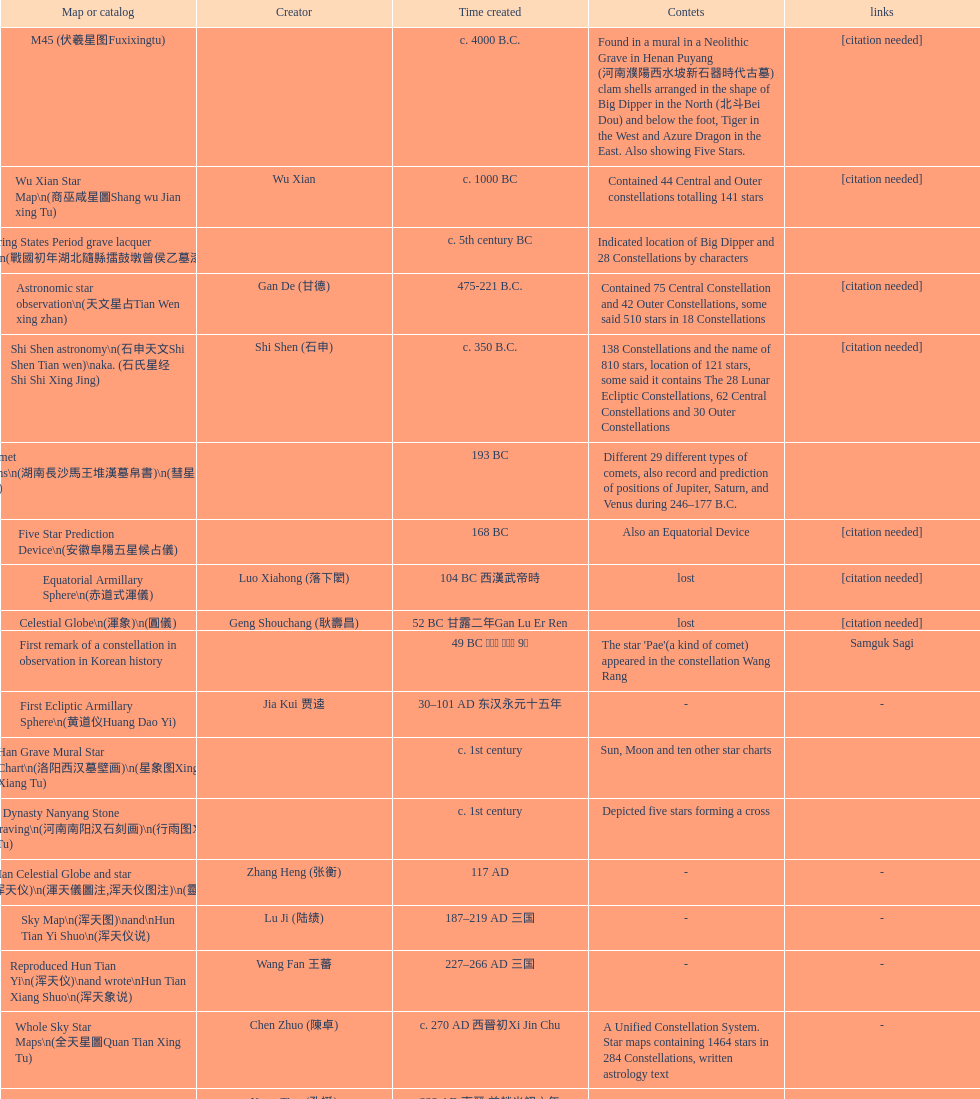Parse the full table. {'header': ['Map or catalog', 'Creator', 'Time created', 'Contets', 'links'], 'rows': [['M45 (伏羲星图Fuxixingtu)', '', 'c. 4000 B.C.', 'Found in a mural in a Neolithic Grave in Henan Puyang (河南濮陽西水坡新石器時代古墓) clam shells arranged in the shape of Big Dipper in the North (北斗Bei Dou) and below the foot, Tiger in the West and Azure Dragon in the East. Also showing Five Stars.', '[citation needed]'], ['Wu Xian Star Map\\n(商巫咸星圖Shang wu Jian xing Tu)', 'Wu Xian', 'c. 1000 BC', 'Contained 44 Central and Outer constellations totalling 141 stars', '[citation needed]'], ['Warring States Period grave lacquer box\\n(戰國初年湖北隨縣擂鼓墩曾侯乙墓漆箱)', '', 'c. 5th century BC', 'Indicated location of Big Dipper and 28 Constellations by characters', ''], ['Astronomic star observation\\n(天文星占Tian Wen xing zhan)', 'Gan De (甘德)', '475-221 B.C.', 'Contained 75 Central Constellation and 42 Outer Constellations, some said 510 stars in 18 Constellations', '[citation needed]'], ['Shi Shen astronomy\\n(石申天文Shi Shen Tian wen)\\naka. (石氏星经 Shi Shi Xing Jing)', 'Shi Shen (石申)', 'c. 350 B.C.', '138 Constellations and the name of 810 stars, location of 121 stars, some said it contains The 28 Lunar Ecliptic Constellations, 62 Central Constellations and 30 Outer Constellations', '[citation needed]'], ['Han Comet Diagrams\\n(湖南長沙馬王堆漢墓帛書)\\n(彗星圖Meng xing Tu)', '', '193 BC', 'Different 29 different types of comets, also record and prediction of positions of Jupiter, Saturn, and Venus during 246–177 B.C.', ''], ['Five Star Prediction Device\\n(安徽阜陽五星候占儀)', '', '168 BC', 'Also an Equatorial Device', '[citation needed]'], ['Equatorial Armillary Sphere\\n(赤道式渾儀)', 'Luo Xiahong (落下閎)', '104 BC 西漢武帝時', 'lost', '[citation needed]'], ['Celestial Globe\\n(渾象)\\n(圓儀)', 'Geng Shouchang (耿壽昌)', '52 BC 甘露二年Gan Lu Er Ren', 'lost', '[citation needed]'], ['First remark of a constellation in observation in Korean history', '', '49 BC 혁거세 거서간 9년', "The star 'Pae'(a kind of comet) appeared in the constellation Wang Rang", 'Samguk Sagi'], ['First Ecliptic Armillary Sphere\\n(黄道仪Huang Dao Yi)', 'Jia Kui 贾逵', '30–101 AD 东汉永元十五年', '-', '-'], ['Han Grave Mural Star Chart\\n(洛阳西汉墓壁画)\\n(星象图Xing Xiang Tu)', '', 'c. 1st century', 'Sun, Moon and ten other star charts', ''], ['Han Dynasty Nanyang Stone Engraving\\n(河南南阳汉石刻画)\\n(行雨图Xing Yu Tu)', '', 'c. 1st century', 'Depicted five stars forming a cross', ''], ['Eastern Han Celestial Globe and star maps\\n(浑天仪)\\n(渾天儀圖注,浑天仪图注)\\n(靈憲,灵宪)', 'Zhang Heng (张衡)', '117 AD', '-', '-'], ['Sky Map\\n(浑天图)\\nand\\nHun Tian Yi Shuo\\n(浑天仪说)', 'Lu Ji (陆绩)', '187–219 AD 三国', '-', '-'], ['Reproduced Hun Tian Yi\\n(浑天仪)\\nand wrote\\nHun Tian Xiang Shuo\\n(浑天象说)', 'Wang Fan 王蕃', '227–266 AD 三国', '-', '-'], ['Whole Sky Star Maps\\n(全天星圖Quan Tian Xing Tu)', 'Chen Zhuo (陳卓)', 'c. 270 AD 西晉初Xi Jin Chu', 'A Unified Constellation System. Star maps containing 1464 stars in 284 Constellations, written astrology text', '-'], ['Equatorial Armillary Sphere\\n(渾儀Hun Xi)', 'Kong Ting (孔挺)', '323 AD 東晉 前趙光初六年', 'level being used in this kind of device', '-'], ['Northern Wei Period Iron Armillary Sphere\\n(鐵渾儀)', 'Hu Lan (斛蘭)', 'Bei Wei\\plevel being used in this kind of device', '-', ''], ['Southern Dynasties Period Whole Sky Planetarium\\n(渾天象Hun Tian Xiang)', 'Qian Lezhi (錢樂之)', '443 AD 南朝劉宋元嘉年間', 'used red, black and white to differentiate stars from different star maps from Shi Shen, Gan De and Wu Xian 甘, 石, 巫三家星', '-'], ['Northern Wei Grave Dome Star Map\\n(河南洛陽北魏墓頂星圖)', '', '526 AD 北魏孝昌二年', 'about 300 stars, including the Big Dipper, some stars are linked by straight lines to form constellation. The Milky Way is also shown.', ''], ['Water-powered Planetarium\\n(水力渾天儀)', 'Geng Xun (耿詢)', 'c. 7th century 隋初Sui Chu', '-', '-'], ['Lingtai Miyuan\\n(靈台秘苑)', 'Yu Jicai (庾季才) and Zhou Fen (周墳)', '604 AD 隋Sui', 'incorporated star maps from different sources', '-'], ['Tang Dynasty Whole Sky Ecliptic Armillary Sphere\\n(渾天黃道儀)', 'Li Chunfeng 李淳風', '667 AD 貞觀七年', 'including Elliptic and Moon orbit, in addition to old equatorial design', '-'], ['The Dunhuang star map\\n(燉煌)', 'Dun Huang', '705–710 AD', '1,585 stars grouped into 257 clusters or "asterisms"', ''], ['Turfan Tomb Star Mural\\n(新疆吐鲁番阿斯塔那天文壁画)', '', '250–799 AD 唐', '28 Constellations, Milkyway and Five Stars', ''], ['Picture of Fuxi and Nüwa 新疆阿斯達那唐墓伏羲Fu Xi 女媧NV Wa像Xiang', '', 'Tang Dynasty', 'Picture of Fuxi and Nuwa together with some constellations', 'Image:Nuva fuxi.gif'], ['Tang Dynasty Armillary Sphere\\n(唐代渾儀Tang Dai Hun Xi)\\n(黃道遊儀Huang dao you xi)', 'Yixing Monk 一行和尚 (张遂)Zhang Sui and Liang Lingzan 梁令瓚', '683–727 AD', 'based on Han Dynasty Celestial Globe, recalibrated locations of 150 stars, determined that stars are moving', ''], ['Tang Dynasty Indian Horoscope Chart\\n(梵天火羅九曜)', 'Yixing Priest 一行和尚 (张遂)\\pZhang Sui\\p683–727 AD', 'simple diagrams of the 28 Constellation', '', ''], ['Kitora Kofun 法隆寺FaLong Si\u3000キトラ古墳 in Japan', '', 'c. late 7th century – early 8th century', 'Detailed whole sky map', ''], ['Treatise on Astrology of the Kaiyuan Era\\n(開元占経,开元占经Kai Yuan zhang Jing)', 'Gautama Siddha', '713 AD –', 'Collection of the three old star charts from Shi Shen, Gan De and Wu Xian. One of the most renowned collection recognized academically.', '-'], ['Big Dipper\\n(山東嘉祥武梁寺石刻北斗星)', '', '–', 'showing stars in Big Dipper', ''], ['Prajvalonisa Vjrabhairava Padvinasa-sri-dharani Scroll found in Japan 熾盛光佛頂大威德銷災吉祥陀羅尼經卷首扉畫', '', '972 AD 北宋開寶五年', 'Chinese 28 Constellations and Western Zodiac', '-'], ['Tangut Khara-Khoto (The Black City) Star Map 西夏黑水城星圖', '', '940 AD', 'A typical Qian Lezhi Style Star Map', '-'], ['Star Chart 五代吳越文穆王前元瓘墓石刻星象圖', '', '941–960 AD', '-', ''], ['Ancient Star Map 先天图 by 陈抟Chen Tuan', '', 'c. 11th Chen Tuan 宋Song', 'Perhaps based on studying of Puyong Ancient Star Map', 'Lost'], ['Song Dynasty Bronze Armillary Sphere 北宋至道銅渾儀', 'Han Xianfu 韓顯符', '1006 AD 宋道元年十二月', 'Similar to the Simplified Armillary by Kong Ting 孔挺, 晁崇 Chao Chong, 斛蘭 Hu Lan', '-'], ['Song Dynasty Bronze Armillary Sphere 北宋天文院黄道渾儀', 'Shu Yijian 舒易簡, Yu Yuan 于渊, Zhou Cong 周琮', '宋皇祐年中', 'Similar to the Armillary by Tang Dynasty Liang Lingzan 梁令瓚 and Yi Xing 一行', '-'], ['Song Dynasty Armillary Sphere 北宋簡化渾儀', 'Shen Kuo 沈括 and Huangfu Yu 皇甫愈', '1089 AD 熙寧七年', 'Simplied version of Tang Dynasty Device, removed the rarely used moon orbit.', '-'], ['Five Star Charts (新儀象法要)', 'Su Song 蘇頌', '1094 AD', '1464 stars grouped into 283 asterisms', 'Image:Su Song Star Map 1.JPG\\nImage:Su Song Star Map 2.JPG'], ['Song Dynasty Water-powered Planetarium 宋代 水运仪象台', 'Su Song 蘇頌 and Han Gonglian 韩公廉', 'c. 11th century', '-', ''], ['Liao Dynasty Tomb Dome Star Map 遼宣化张世卿墓頂星圖', '', '1116 AD 遼天庆六年', 'shown both the Chinese 28 Constellation encircled by Babylonian Zodiac', ''], ["Star Map in a woman's grave (江西德安 南宋周氏墓星相图)", '', '1127–1279 AD', 'Milky Way and 57 other stars.', ''], ['Hun Tian Yi Tong Xing Xiang Quan Tu, Suzhou Star Chart (蘇州石刻天文圖),淳祐天文図', 'Huang Shang (黃裳)', 'created in 1193, etched to stone in 1247 by Wang Zhi Yuan 王致遠', '1434 Stars grouped into 280 Asterisms in Northern Sky map', ''], ['Yuan Dynasty Simplified Armillary Sphere 元代簡儀', 'Guo Shou Jing 郭守敬', '1276–1279', 'Further simplied version of Song Dynasty Device', ''], ['Japanese Star Chart 格子月進図', '', '1324', 'Similar to Su Song Star Chart, original burned in air raids during World War II, only pictures left. Reprinted in 1984 by 佐佐木英治', ''], ['天象列次分野之図(Cheonsang Yeolcha Bunyajido)', '', '1395', 'Korean versions of Star Map in Stone. It was made in Chosun Dynasty and the constellation names were written in Chinese letter. The constellations as this was found in Japanese later. Contained 1,464 stars.', ''], ['Japanese Star Chart 瀧谷寺 天之図', '', 'c. 14th or 15th centuries 室町中期以前', '-', ''], ["Korean King Sejong's Armillary sphere", '', '1433', '-', ''], ['Star Chart', 'Mao Kun 茅坤', 'c. 1422', 'Polaris compared with Southern Cross and Alpha Centauri', 'zh:郑和航海图'], ['Korean Tomb', '', 'c. late 14th century', 'Big Dipper', ''], ['Ming Ancient Star Chart 北京隆福寺(古星圖)', '', 'c. 1453 明代', '1420 Stars, possibly based on old star maps from Tang Dynasty', ''], ['Chanshu Star Chart (明常熟石刻天文圖)', '', '1506', 'Based on Suzhou Star Chart, Northern Sky observed at 36.8 degrees North Latitude, 1466 stars grouped into 284 asterism', '-'], ['Ming Dynasty Star Map (渾蓋通憲圖說)', 'Matteo Ricci 利玛窦Li Ma Dou, recorded by Li Zhizao 李之藻', 'c. 1550', '-', ''], ['Tian Wun Tu (天问图)', 'Xiao Yun Cong 萧云从', 'c. 1600', 'Contained mapping of 12 constellations and 12 animals', ''], ['Zhou Tian Xuan Ji Tu (周天璇玑图) and He He Si Xiang Tu (和合四象圖) in Xing Ming Gui Zhi (性命圭旨)', 'by 尹真人高第弟子 published by 余永宁', '1615', 'Drawings of Armillary Sphere and four Chinese Celestial Animals with some notes. Related to Taoism.', ''], ['Korean Astronomy Book "Selected and Systematized Astronomy Notes" 天文類抄', '', '1623~1649', 'Contained some star maps', ''], ['Ming Dynasty General Star Map (赤道南北兩總星圖)', 'Xu Guang ci 徐光啟 and Adam Schall von Bell Tang Ruo Wang湯若望', '1634', '-', ''], ['Ming Dynasty diagrams of Armillary spheres and Celestial Globes', 'Xu Guang ci 徐光啟', 'c. 1699', '-', ''], ['Ming Dynasty Planetarium Machine (渾象 Hui Xiang)', '', 'c. 17th century', 'Ecliptic, Equator, and dividers of 28 constellation', ''], ['Copper Plate Star Map stored in Korea', '', '1652 順治九年shun zi jiu nian', '-', ''], ['Japanese Edo period Star Chart 天象列次之図 based on 天象列次分野之図 from Korean', 'Harumi Shibukawa 渋川春海Bu Chuan Chun Mei(保井春海Bao Jing Chun Mei)', '1670 寛文十年', '-', ''], ['The Celestial Globe 清康熙 天體儀', 'Ferdinand Verbiest 南懷仁', '1673', '1876 stars grouped into 282 asterisms', ''], ['Picture depicted Song Dynasty fictional astronomer (呉用 Wu Yong) with a Celestial Globe (天體儀)', 'Japanese painter', '1675', 'showing top portion of a Celestial Globe', 'File:Chinese astronomer 1675.jpg'], ['Japanese Edo period Star Chart 天文分野之図', 'Harumi Shibukawa 渋川春海BuJingChun Mei (保井春海Bao JingChunMei)', '1677 延宝五年', '-', ''], ['Korean star map in stone', '', '1687', '-', ''], ['Japanese Edo period Star Chart 天文図解', '井口常範', '1689 元禄2年', '-', '-'], ['Japanese Edo period Star Chart 古暦便覧備考', '苗村丈伯Mao Chun Zhang Bo', '1692 元禄5年', '-', '-'], ['Japanese star chart', 'Harumi Yasui written in Chinese', '1699 AD', 'A Japanese star chart of 1699 showing lunar stations', ''], ['Japanese Edo period Star Chart 天文成象Tian Wen Cheng xiang', '(渋川昔尹She Chuan Xi Yin) (保井昔尹Bao Jing Xi Yin)', '1699 元禄十二年', 'including Stars from Wu Shien (44 Constellation, 144 stars) in yellow; Gan De (118 Constellations, 511 stars) in black; Shi Shen (138 Constellations, 810 stars) in red and Harumi Shibukawa (61 Constellations, 308 stars) in blue;', ''], ['Japanese Star Chart 改正天文図説', '', 'unknown', 'Included stars from Harumi Shibukawa', ''], ['Korean Star Map Stone', '', 'c. 17th century', '-', ''], ['Korean Star Map', '', 'c. 17th century', '-', ''], ['Ceramic Ink Sink Cover', '', 'c. 17th century', 'Showing Big Dipper', ''], ['Korean Star Map Cube 方星圖', 'Italian Missionary Philippus Maria Grimardi 閔明我 (1639~1712)', 'c. early 18th century', '-', ''], ['Star Chart preserved in Japan based on a book from China 天経或問', 'You Zi liu 游子六', '1730 AD 江戸時代 享保15年', 'A Northern Sky Chart in Chinese', ''], ['Star Chart 清蒙文石刻(欽天監繪製天文圖) in Mongolia', '', '1727–1732 AD', '1550 stars grouped into 270 starisms.', ''], ['Korean Star Maps, North and South to the Eclliptic 黃道南北恒星圖', '', '1742', '-', ''], ['Japanese Edo period Star Chart 天経或問註解図巻\u3000下', '入江脩敬Ru Jiang YOu Jing', '1750 寛延3年', '-', '-'], ['Reproduction of an ancient device 璇璣玉衡', 'Dai Zhen 戴震', '1723–1777 AD', 'based on ancient record and his own interpretation', 'Could be similar to'], ['Rock Star Chart 清代天文石', '', 'c. 18th century', 'A Star Chart and general Astronomy Text', ''], ['Korean Complete Star Map (渾天全圖)', '', 'c. 18th century', '-', ''], ['Qing Dynasty Star Catalog (儀象考成,仪象考成)恒星表 and Star Map 黄道南北両星総図', 'Yun Lu 允禄 and Ignatius Kogler 戴进贤Dai Jin Xian 戴進賢, a German', 'Device made in 1744, book completed in 1757 清乾隆年间', '300 Constellations and 3083 Stars. Referenced Star Catalogue published by John Flamsteed', ''], ['Jingban Tianwen Quantu by Ma Junliang 马俊良', '', '1780–90 AD', 'mapping nations to the sky', ''], ['Japanese Edo period Illustration of a Star Measuring Device 平天儀図解', 'Yan Qiao Shan Bing Heng 岩橋善兵衛', '1802 Xiang He Er Nian 享和二年', '-', 'The device could be similar to'], ['North Sky Map 清嘉庆年间Huang Dao Zhong Xi He Tu(黄道中西合图)', 'Xu Choujun 徐朝俊', '1807 AD', 'More than 1000 stars and the 28 consellation', ''], ['Japanese Edo period Star Chart 天象総星之図', 'Chao Ye Bei Shui 朝野北水', '1814 文化十一年', '-', '-'], ['Japanese Edo period Star Chart 新制天球星象記', '田中政均', '1815 文化十二年', '-', '-'], ['Japanese Edo period Star Chart 天球図', '坂部廣胖', '1816 文化十三年', '-', '-'], ['Chinese Star map', 'John Reeves esq', '1819 AD', 'Printed map showing Chinese names of stars and constellations', ''], ['Japanese Edo period Star Chart 昊天図説詳解', '佐藤祐之', '1824 文政七年', '-', '-'], ['Japanese Edo period Star Chart 星図歩天歌', '小島好謙 and 鈴木世孝', '1824 文政七年', '-', '-'], ['Japanese Edo period Star Chart', '鈴木世孝', '1824 文政七年', '-', '-'], ['Japanese Edo period Star Chart 天象管鈔 天体図 (天文星象図解)', '長久保赤水', '1824 文政七年', '-', ''], ['Japanese Edo period Star Measuring Device 中星儀', '足立信順Zhu Li Xin Shun', '1824 文政七年', '-', '-'], ['Japanese Star Map 天象一覧図 in Kanji', '桜田虎門', '1824 AD 文政７年', 'Printed map showing Chinese names of stars and constellations', ''], ['Korean Star Map 天象列次分野之図 in Kanji', '', 'c. 19th century', 'Printed map showing Chinese names of stars and constellations', '[18]'], ['Korean Star Map', '', 'c. 19th century, late Choson Period', '-', ''], ['Korean Star maps: Star Map South to the Ecliptic 黃道南恒星圖 and Star Map South to the Ecliptic 黃道北恒星圖', '', 'c. 19th century', 'Perhaps influenced by Adam Schall von Bell Tang Ruo wang 湯若望 (1591–1666) and P. Ignatius Koegler 戴進賢 (1680–1748)', ''], ['Korean Complete map of the celestial sphere (渾天全圖)', '', 'c. 19th century', '-', ''], ['Korean Book of Stars 經星', '', 'c. 19th century', 'Several star maps', ''], ['Japanese Edo period Star Chart 方円星図,方圓星図 and 増補分度星図方図', '石坂常堅', '1826b文政9年', '-', '-'], ['Japanese Star Chart', '伊能忠誨', 'c. 19th century', '-', '-'], ['Japanese Edo period Star Chart 天球図説', '古筆源了材', '1835 天保6年', '-', '-'], ['Qing Dynasty Star Catalog (儀象考成續編)星表', '', '1844', 'Appendix to Yi Xian Kao Cheng, listed 3240 stars (added 163, removed 6)', ''], ['Stars map (恒星赤道経緯度図)stored in Japan', '', '1844 道光24年 or 1848', '-', '-'], ['Japanese Edo period Star Chart 経緯簡儀用法', '藤岡有貞', '1845 弘化２年', '-', '-'], ['Japanese Edo period Star Chart 分野星図', '高塚福昌, 阿部比輔, 上条景弘', '1849 嘉永2年', '-', '-'], ['Japanese Late Edo period Star Chart 天文図屏風', '遠藤盛俊', 'late Edo Period 江戸時代後期', '-', '-'], ['Japanese Star Chart 天体図', '三浦梅園', '-', '-', '-'], ['Japanese Star Chart 梅園星図', '高橋景保', '-', '-', ''], ['Korean Book of New Song of the Sky Pacer 新法步天歌', '李俊養', '1862', 'Star maps and a revised version of the Song of Sky Pacer', ''], ['Stars South of Equator, Stars North of Equator (赤道南恆星圖,赤道北恆星圖)', '', '1875～1908 清末光緒年間', 'Similar to Ming Dynasty General Star Map', ''], ['Fuxi 64 gua 28 xu wood carving 天水市卦台山伏羲六十四卦二十八宿全图', '', 'modern', '-', '-'], ['Korean Map of Heaven and Earth 天地圖', '', 'c. 19th century', '28 Constellations and geographic map', ''], ['Korean version of 28 Constellation 列宿圖', '', 'c. 19th century', '28 Constellations, some named differently from their Chinese counterparts', ''], ['Korean Star Chart 渾天図', '朴?', '-', '-', '-'], ['Star Chart in a Dao Temple 玉皇山道觀星圖', '', '1940 AD', '-', '-'], ['Simplified Chinese and Western Star Map', 'Yi Shi Tong 伊世同', 'Aug. 1963', 'Star Map showing Chinese Xingquan and Western Constellation boundaries', ''], ['Sky Map', 'Yu Xi Dao Ren 玉溪道人', '1987', 'Star Map with captions', ''], ['The Chinese Sky during the Han Constellating Stars and Society', 'Sun Xiaochun and Jacob Kistemaker', '1997 AD', 'An attempt to recreate night sky seen by Chinese 2000 years ago', ''], ['Star map', '', 'Recent', 'An attempt by a Japanese to reconstruct the night sky for a historical event around 235 AD 秋風五丈原', ''], ['Star maps', '', 'Recent', 'Chinese 28 Constellation with Chinese and Japanese captions', ''], ['SinoSky Beta 2.0', '', '2002', 'A computer program capable of showing Chinese Xingguans alongside with western constellations, lists about 700 stars with Chinese names.', ''], ['AEEA Star maps', '', 'Modern', 'Good reconstruction and explanation of Chinese constellations', ''], ['Wikipedia Star maps', '', 'Modern', '-', 'zh:華蓋星'], ['28 Constellations, big dipper and 4 symbols Star map', '', 'Modern', '-', ''], ['Collection of printed star maps', '', 'Modern', '-', ''], ['28 Xu Star map and catalog', '-', 'Modern', 'Stars around ecliptic', ''], ['HNSKY Korean/Chinese Supplement', 'Jeong, Tae-Min(jtm71)/Chuang_Siau_Chin', 'Modern', 'Korean supplement is based on CheonSangYeulChaBunYaZiDo (B.C.100 ~ A.D.100)', ''], ['Stellarium Chinese and Korean Sky Culture', 'G.S.K. Lee; Jeong, Tae-Min(jtm71); Yu-Pu Wang (evanzxcv)', 'Modern', 'Major Xingguans and Star names', ''], ['修真內外火侯全圖 Huo Hou Tu', 'Xi Chun Sheng Chong Hui\\p2005 redrawn, original unknown', 'illustrations of Milkyway and star maps, Chinese constellations in Taoism view', '', ''], ['Star Map with illustrations for Xingguans', '坐井★观星Zuo Jing Guan Xing', 'Modern', 'illustrations for cylindrical and circular polar maps', ''], ['Sky in Google Earth KML', '', 'Modern', 'Attempts to show Chinese Star Maps on Google Earth', '']]} Which astronomical map was made earlier, celestial globe or the han burial site star chart? Celestial Globe. 